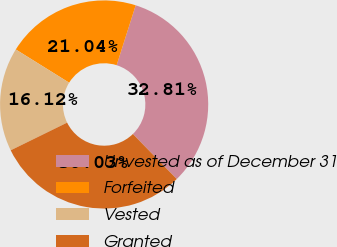Convert chart to OTSL. <chart><loc_0><loc_0><loc_500><loc_500><pie_chart><fcel>Unvested as of December 31<fcel>Forfeited<fcel>Vested<fcel>Granted<nl><fcel>32.81%<fcel>21.04%<fcel>16.12%<fcel>30.03%<nl></chart> 